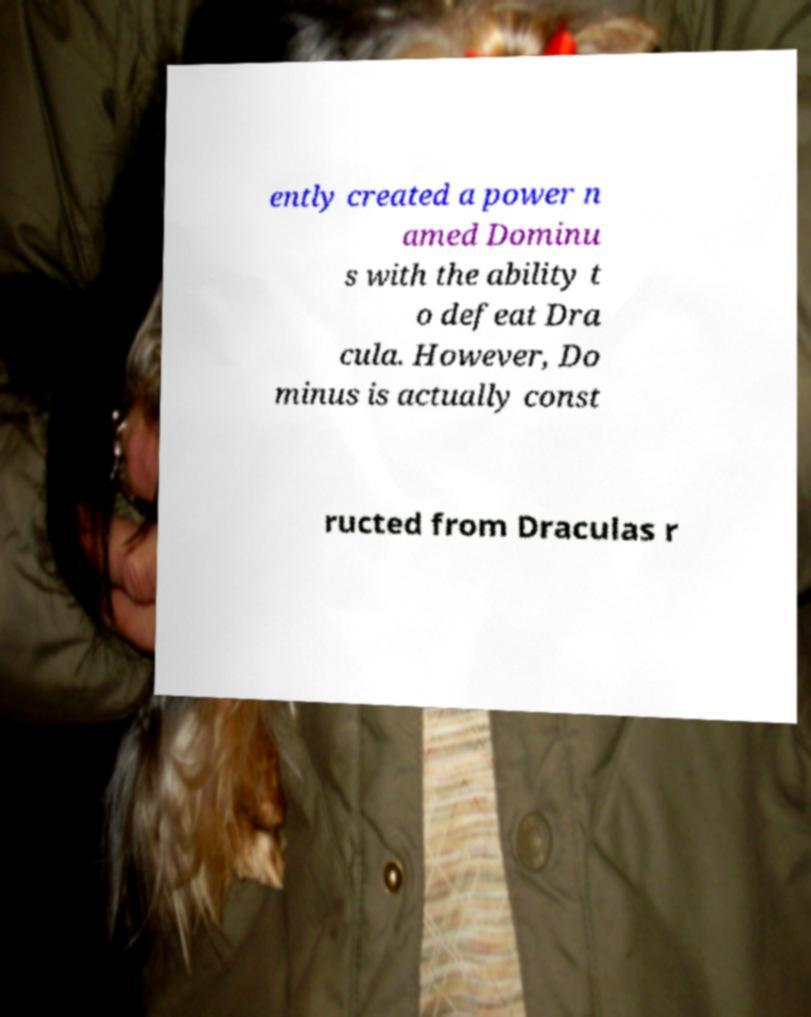Please identify and transcribe the text found in this image. ently created a power n amed Dominu s with the ability t o defeat Dra cula. However, Do minus is actually const ructed from Draculas r 